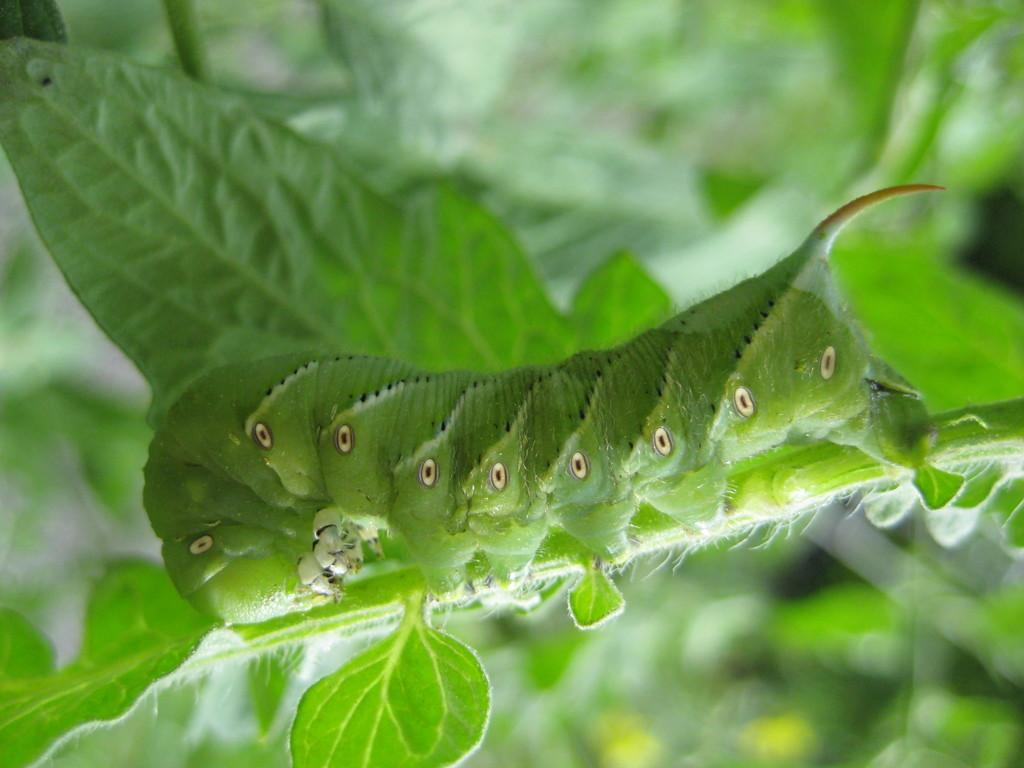What is present on the plant in the image? There is an insect on a plant in the image. How would you describe the background of the image? The background of the image is blurred. What can be seen in the background besides the blurred area? Leaves are visible in the background of the image. What type of quill is the insect using to write on the plant in the image? There is no quill present in the image, and insects do not write. 